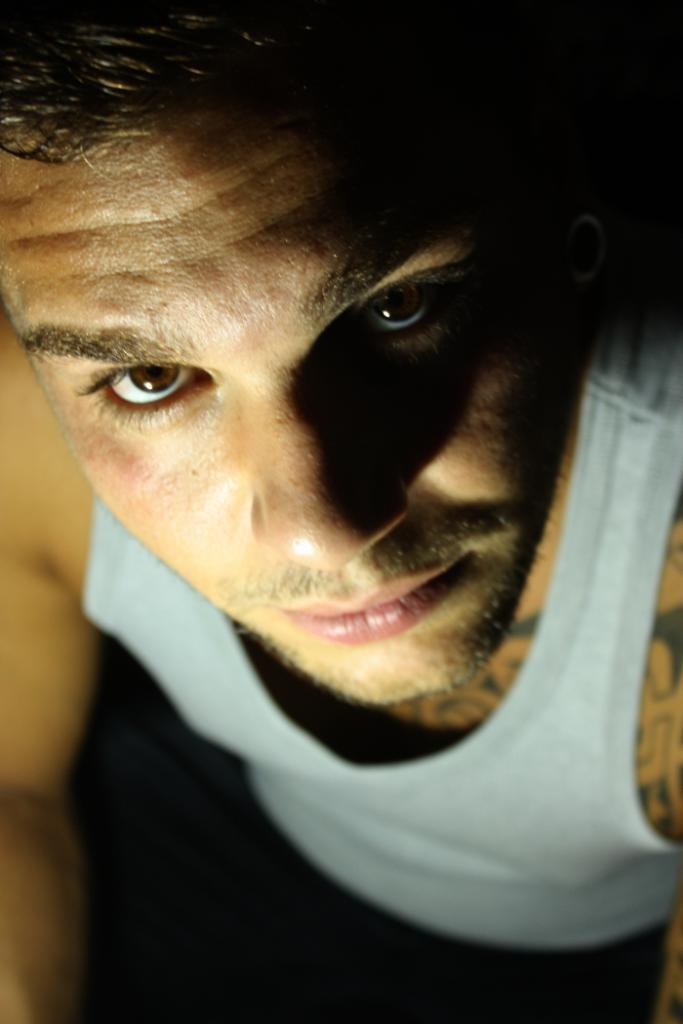Who is present in the image? There is a man in the image. What is the man wearing? The man is wearing a white vest. How many beds are visible in the image? There are no beds visible in the image; it only features a man wearing a white vest. What type of plate is being used by the man in the image? There is no plate present in the image; the man is not shown using any plate. 